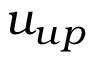Convert formula to latex. <formula><loc_0><loc_0><loc_500><loc_500>u _ { u p }</formula> 